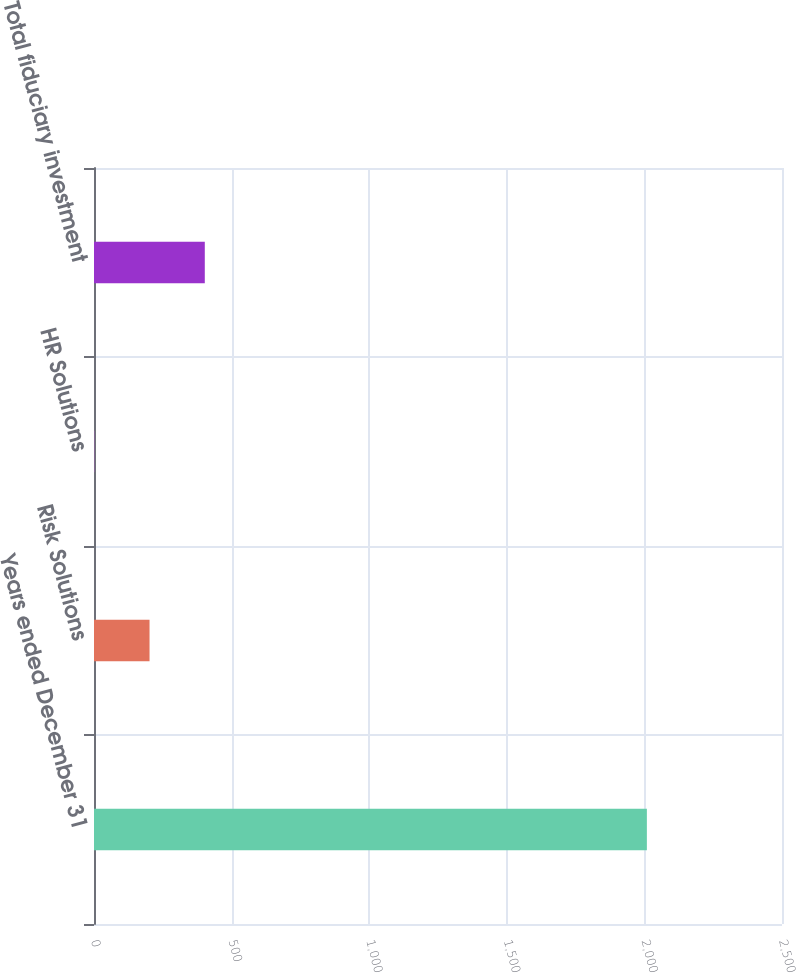Convert chart. <chart><loc_0><loc_0><loc_500><loc_500><bar_chart><fcel>Years ended December 31<fcel>Risk Solutions<fcel>HR Solutions<fcel>Total fiduciary investment<nl><fcel>2009<fcel>201.8<fcel>1<fcel>402.6<nl></chart> 